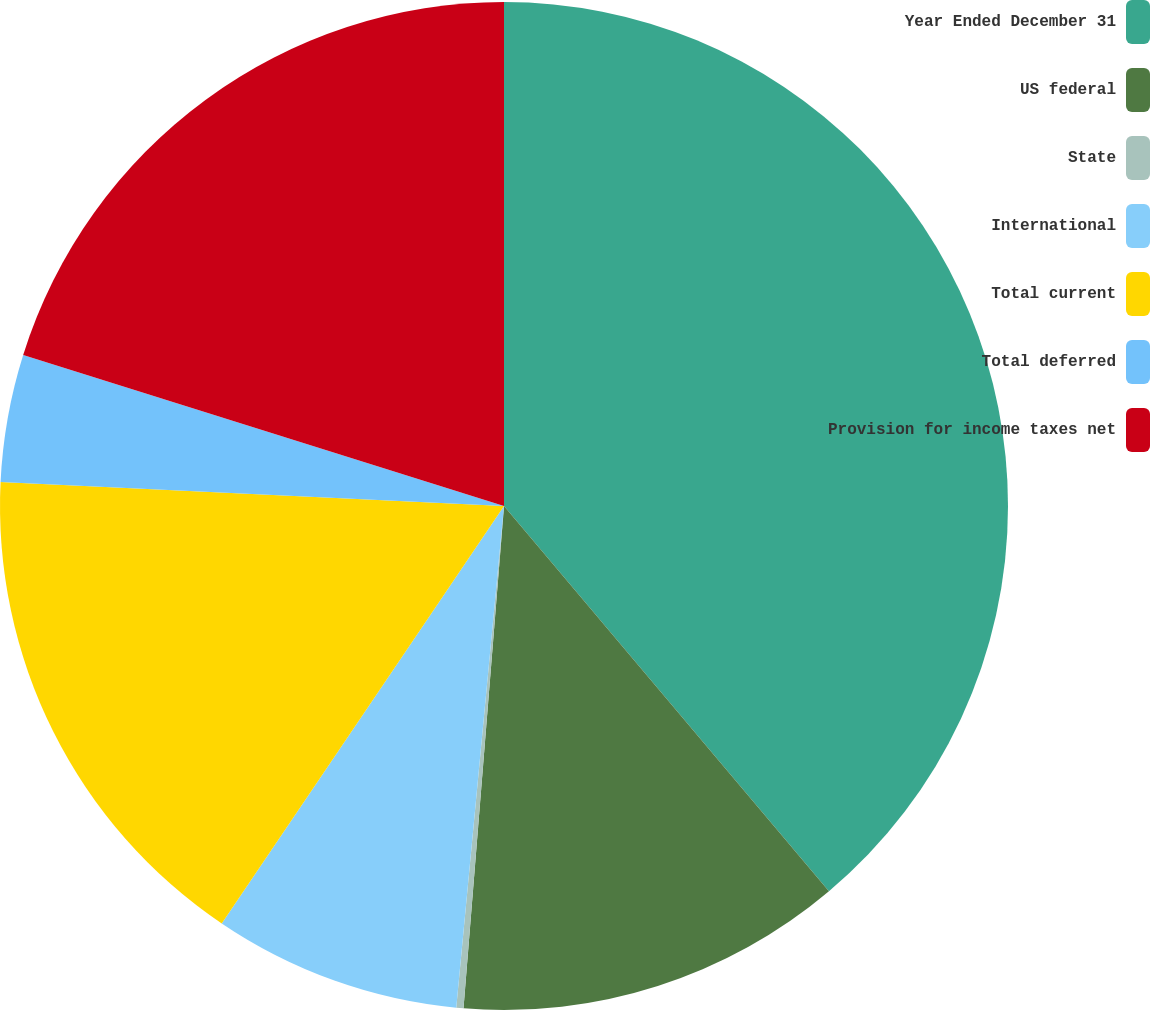<chart> <loc_0><loc_0><loc_500><loc_500><pie_chart><fcel>Year Ended December 31<fcel>US federal<fcel>State<fcel>International<fcel>Total current<fcel>Total deferred<fcel>Provision for income taxes net<nl><fcel>38.84%<fcel>12.43%<fcel>0.23%<fcel>7.95%<fcel>16.29%<fcel>4.09%<fcel>20.15%<nl></chart> 